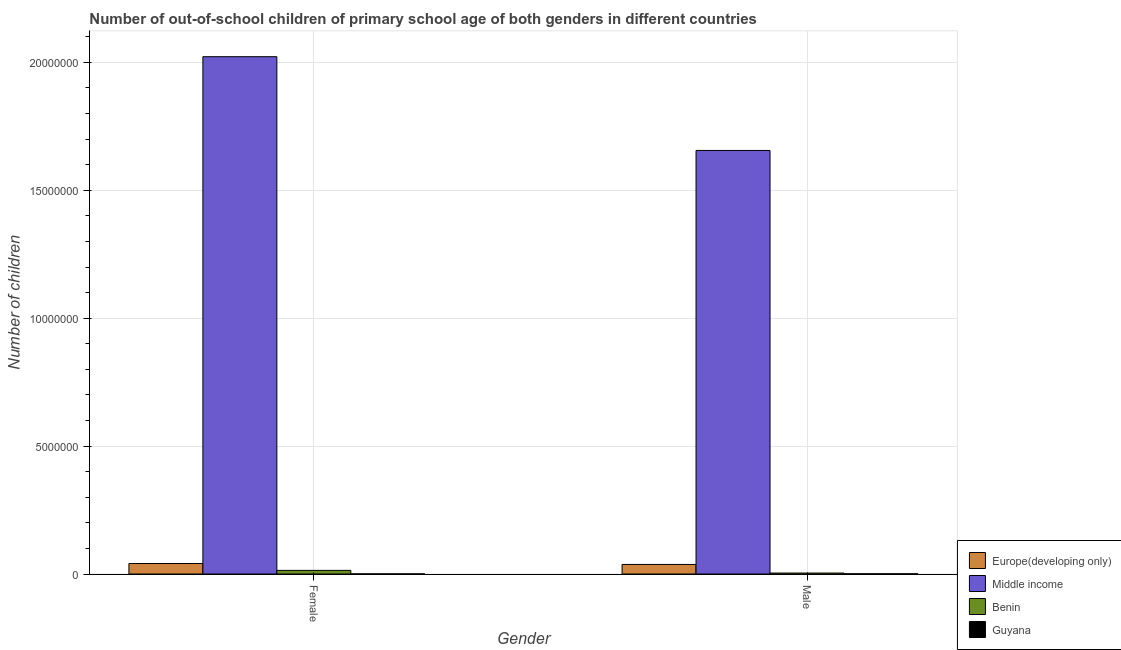How many different coloured bars are there?
Offer a terse response. 4. How many groups of bars are there?
Give a very brief answer. 2. How many bars are there on the 1st tick from the right?
Make the answer very short. 4. What is the label of the 2nd group of bars from the left?
Give a very brief answer. Male. What is the number of male out-of-school students in Guyana?
Ensure brevity in your answer.  8432. Across all countries, what is the maximum number of female out-of-school students?
Provide a short and direct response. 2.02e+07. Across all countries, what is the minimum number of female out-of-school students?
Provide a short and direct response. 4096. In which country was the number of female out-of-school students maximum?
Keep it short and to the point. Middle income. In which country was the number of male out-of-school students minimum?
Give a very brief answer. Guyana. What is the total number of male out-of-school students in the graph?
Your answer should be compact. 1.70e+07. What is the difference between the number of male out-of-school students in Europe(developing only) and that in Benin?
Make the answer very short. 3.35e+05. What is the difference between the number of male out-of-school students in Benin and the number of female out-of-school students in Guyana?
Your response must be concise. 3.38e+04. What is the average number of male out-of-school students per country?
Your answer should be very brief. 4.24e+06. What is the difference between the number of female out-of-school students and number of male out-of-school students in Guyana?
Make the answer very short. -4336. What is the ratio of the number of male out-of-school students in Benin to that in Guyana?
Keep it short and to the point. 4.5. Is the number of male out-of-school students in Middle income less than that in Benin?
Make the answer very short. No. In how many countries, is the number of female out-of-school students greater than the average number of female out-of-school students taken over all countries?
Provide a succinct answer. 1. What does the 3rd bar from the left in Male represents?
Your answer should be very brief. Benin. What does the 2nd bar from the right in Female represents?
Give a very brief answer. Benin. Are all the bars in the graph horizontal?
Keep it short and to the point. No. How many countries are there in the graph?
Your answer should be very brief. 4. What is the difference between two consecutive major ticks on the Y-axis?
Your response must be concise. 5.00e+06. Are the values on the major ticks of Y-axis written in scientific E-notation?
Provide a succinct answer. No. Does the graph contain any zero values?
Provide a succinct answer. No. What is the title of the graph?
Keep it short and to the point. Number of out-of-school children of primary school age of both genders in different countries. What is the label or title of the X-axis?
Keep it short and to the point. Gender. What is the label or title of the Y-axis?
Make the answer very short. Number of children. What is the Number of children of Europe(developing only) in Female?
Your response must be concise. 4.11e+05. What is the Number of children in Middle income in Female?
Your answer should be very brief. 2.02e+07. What is the Number of children of Benin in Female?
Offer a terse response. 1.42e+05. What is the Number of children in Guyana in Female?
Ensure brevity in your answer.  4096. What is the Number of children of Europe(developing only) in Male?
Provide a short and direct response. 3.73e+05. What is the Number of children of Middle income in Male?
Offer a terse response. 1.66e+07. What is the Number of children of Benin in Male?
Keep it short and to the point. 3.79e+04. What is the Number of children in Guyana in Male?
Provide a short and direct response. 8432. Across all Gender, what is the maximum Number of children in Europe(developing only)?
Ensure brevity in your answer.  4.11e+05. Across all Gender, what is the maximum Number of children of Middle income?
Offer a very short reply. 2.02e+07. Across all Gender, what is the maximum Number of children of Benin?
Provide a succinct answer. 1.42e+05. Across all Gender, what is the maximum Number of children of Guyana?
Make the answer very short. 8432. Across all Gender, what is the minimum Number of children of Europe(developing only)?
Your answer should be very brief. 3.73e+05. Across all Gender, what is the minimum Number of children of Middle income?
Your answer should be compact. 1.66e+07. Across all Gender, what is the minimum Number of children in Benin?
Provide a short and direct response. 3.79e+04. Across all Gender, what is the minimum Number of children in Guyana?
Ensure brevity in your answer.  4096. What is the total Number of children of Europe(developing only) in the graph?
Offer a very short reply. 7.84e+05. What is the total Number of children in Middle income in the graph?
Give a very brief answer. 3.68e+07. What is the total Number of children of Benin in the graph?
Keep it short and to the point. 1.80e+05. What is the total Number of children in Guyana in the graph?
Offer a very short reply. 1.25e+04. What is the difference between the Number of children of Europe(developing only) in Female and that in Male?
Your response must be concise. 3.72e+04. What is the difference between the Number of children in Middle income in Female and that in Male?
Offer a very short reply. 3.67e+06. What is the difference between the Number of children of Benin in Female and that in Male?
Offer a very short reply. 1.04e+05. What is the difference between the Number of children in Guyana in Female and that in Male?
Ensure brevity in your answer.  -4336. What is the difference between the Number of children in Europe(developing only) in Female and the Number of children in Middle income in Male?
Make the answer very short. -1.61e+07. What is the difference between the Number of children of Europe(developing only) in Female and the Number of children of Benin in Male?
Keep it short and to the point. 3.73e+05. What is the difference between the Number of children in Europe(developing only) in Female and the Number of children in Guyana in Male?
Your response must be concise. 4.02e+05. What is the difference between the Number of children in Middle income in Female and the Number of children in Benin in Male?
Offer a terse response. 2.02e+07. What is the difference between the Number of children in Middle income in Female and the Number of children in Guyana in Male?
Your response must be concise. 2.02e+07. What is the difference between the Number of children in Benin in Female and the Number of children in Guyana in Male?
Ensure brevity in your answer.  1.34e+05. What is the average Number of children of Europe(developing only) per Gender?
Your answer should be very brief. 3.92e+05. What is the average Number of children in Middle income per Gender?
Make the answer very short. 1.84e+07. What is the average Number of children in Benin per Gender?
Keep it short and to the point. 9.00e+04. What is the average Number of children of Guyana per Gender?
Offer a terse response. 6264. What is the difference between the Number of children in Europe(developing only) and Number of children in Middle income in Female?
Offer a terse response. -1.98e+07. What is the difference between the Number of children in Europe(developing only) and Number of children in Benin in Female?
Provide a short and direct response. 2.68e+05. What is the difference between the Number of children of Europe(developing only) and Number of children of Guyana in Female?
Your answer should be very brief. 4.06e+05. What is the difference between the Number of children in Middle income and Number of children in Benin in Female?
Your answer should be very brief. 2.01e+07. What is the difference between the Number of children in Middle income and Number of children in Guyana in Female?
Offer a very short reply. 2.02e+07. What is the difference between the Number of children of Benin and Number of children of Guyana in Female?
Your answer should be compact. 1.38e+05. What is the difference between the Number of children of Europe(developing only) and Number of children of Middle income in Male?
Provide a short and direct response. -1.62e+07. What is the difference between the Number of children in Europe(developing only) and Number of children in Benin in Male?
Ensure brevity in your answer.  3.35e+05. What is the difference between the Number of children of Europe(developing only) and Number of children of Guyana in Male?
Your answer should be very brief. 3.65e+05. What is the difference between the Number of children in Middle income and Number of children in Benin in Male?
Your answer should be compact. 1.65e+07. What is the difference between the Number of children of Middle income and Number of children of Guyana in Male?
Your answer should be compact. 1.65e+07. What is the difference between the Number of children in Benin and Number of children in Guyana in Male?
Your answer should be compact. 2.95e+04. What is the ratio of the Number of children of Europe(developing only) in Female to that in Male?
Your answer should be compact. 1.1. What is the ratio of the Number of children of Middle income in Female to that in Male?
Keep it short and to the point. 1.22. What is the ratio of the Number of children of Benin in Female to that in Male?
Provide a short and direct response. 3.75. What is the ratio of the Number of children of Guyana in Female to that in Male?
Make the answer very short. 0.49. What is the difference between the highest and the second highest Number of children of Europe(developing only)?
Your answer should be compact. 3.72e+04. What is the difference between the highest and the second highest Number of children in Middle income?
Provide a succinct answer. 3.67e+06. What is the difference between the highest and the second highest Number of children of Benin?
Keep it short and to the point. 1.04e+05. What is the difference between the highest and the second highest Number of children of Guyana?
Offer a very short reply. 4336. What is the difference between the highest and the lowest Number of children in Europe(developing only)?
Offer a terse response. 3.72e+04. What is the difference between the highest and the lowest Number of children in Middle income?
Keep it short and to the point. 3.67e+06. What is the difference between the highest and the lowest Number of children in Benin?
Your answer should be very brief. 1.04e+05. What is the difference between the highest and the lowest Number of children of Guyana?
Your answer should be compact. 4336. 